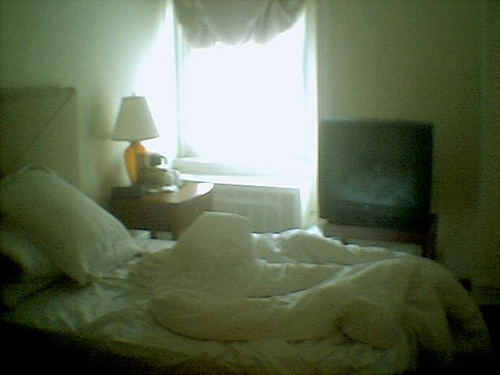Describe the objects in this image and their specific colors. I can see bed in darkgreen and black tones and tv in darkgreen and black tones in this image. 